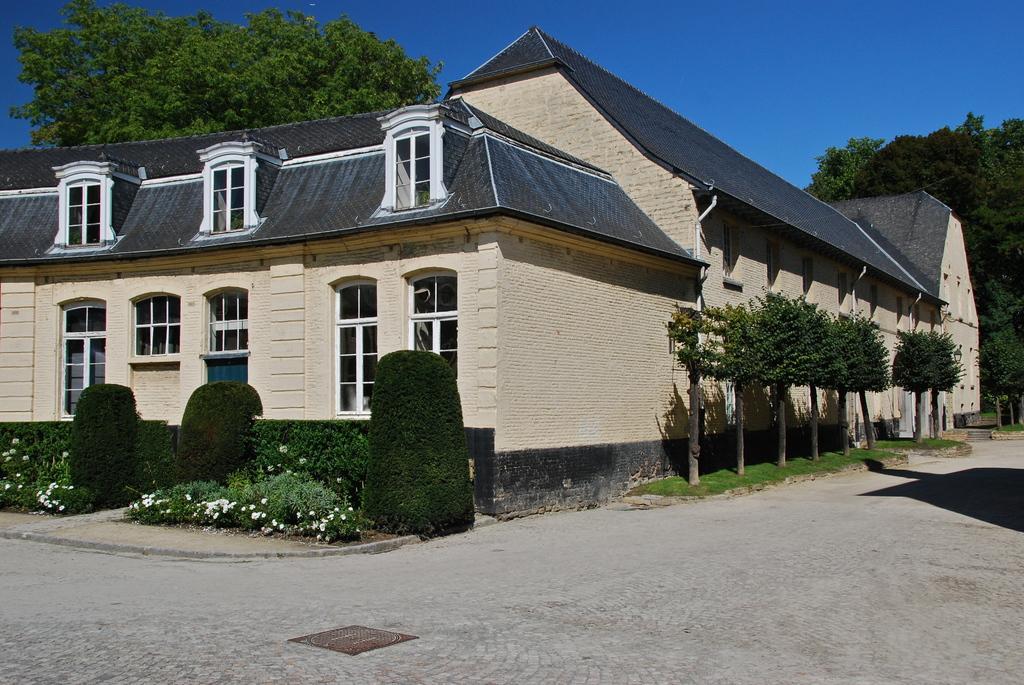Describe this image in one or two sentences. In this picture there are houses in the center of the image and there are windows on the houses and there are plants and flower plants on the right and left side of the image and there are trees in the background area of the image. 